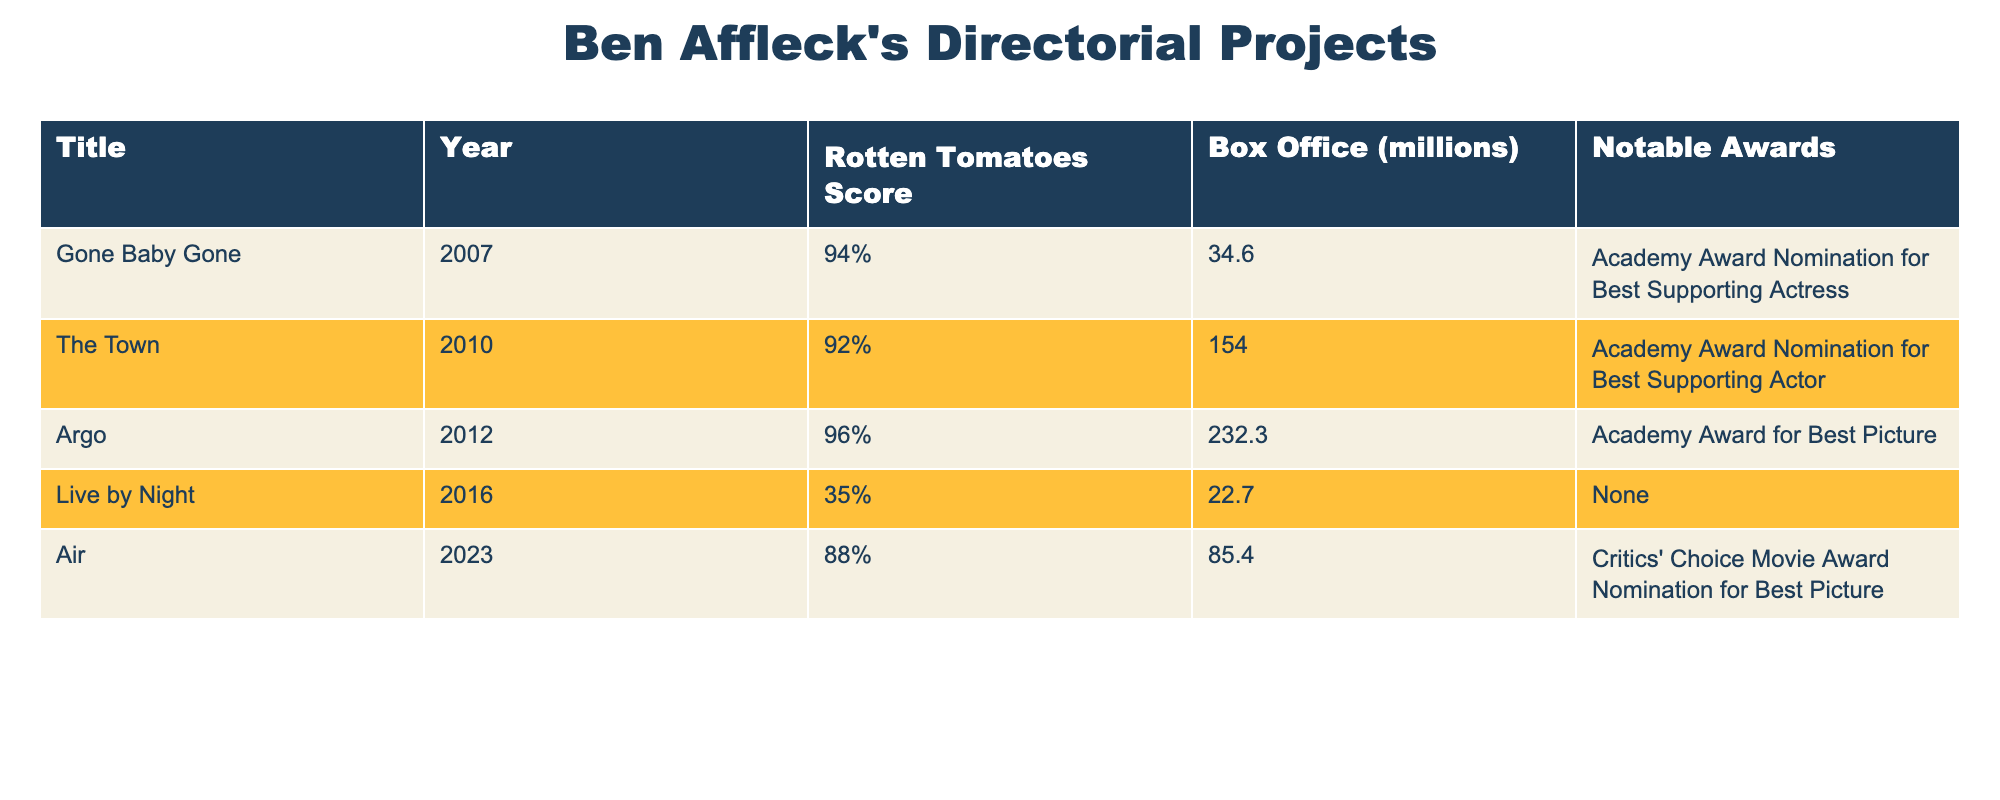What is the Rotten Tomatoes score of "Argo"? The table lists "Argo" under the Title column with a corresponding Rotten Tomatoes score of 96%.
Answer: 96% Which film had the highest box office revenue? The table shows that "Argo" had the highest box office revenue at 232.3 million, compared to other films listed.
Answer: Argo What is the average Rotten Tomatoes score of all the films directed by Ben Affleck? Adding the scores: 94 + 92 + 96 + 35 + 88 = 405. There are 5 films, so the average is 405/5 = 81%.
Answer: 81% Did "Live by Night" receive any notable awards? According to the table, "Live by Night" is listed with no notable awards, indicating it did not receive any.
Answer: No How does the box office revenue of "Live by Night" compare to the average of the others? The box office revenue of "Live by Night" is 22.7 million. For the others: (34.6 + 154.0 + 232.3 + 85.4) = 506.3 million, averaging 506.3/4 = 126.575 million. Since 22.7 million is significantly lower than 126.575 million, it is much below average.
Answer: Below average Which film had the lowest Rotten Tomatoes score? The table indicates that "Live by Night" has the lowest score at 35%, which is lower than the other films.
Answer: Live by Night What notable award did "The Town" receive? "The Town" received an Academy Award nomination for Best Supporting Actor, as indicated in the respective column of the table.
Answer: Academy Award Nomination for Best Supporting Actor Considering the films listed, which had the best critical reception based on Rotten Tomatoes score? "Argo" had the highest Rotten Tomatoes score at 96%, indicating it had the best critical reception among the listed films.
Answer: Argo Is it true that "Air" and "Gone Baby Gone" both have Rotten Tomatoes scores over 80%? Checking the table: "Air" has 88% and "Gone Baby Gone" has 94%, both above 80%. Therefore, the statement is true.
Answer: True What is the total box office revenue of the films directed by Ben Affleck? Summing the box office revenues: 34.6 + 154.0 + 232.3 + 22.7 + 85.4 = 528 million. Therefore, the total box office revenue is 528 million.
Answer: 528 million 